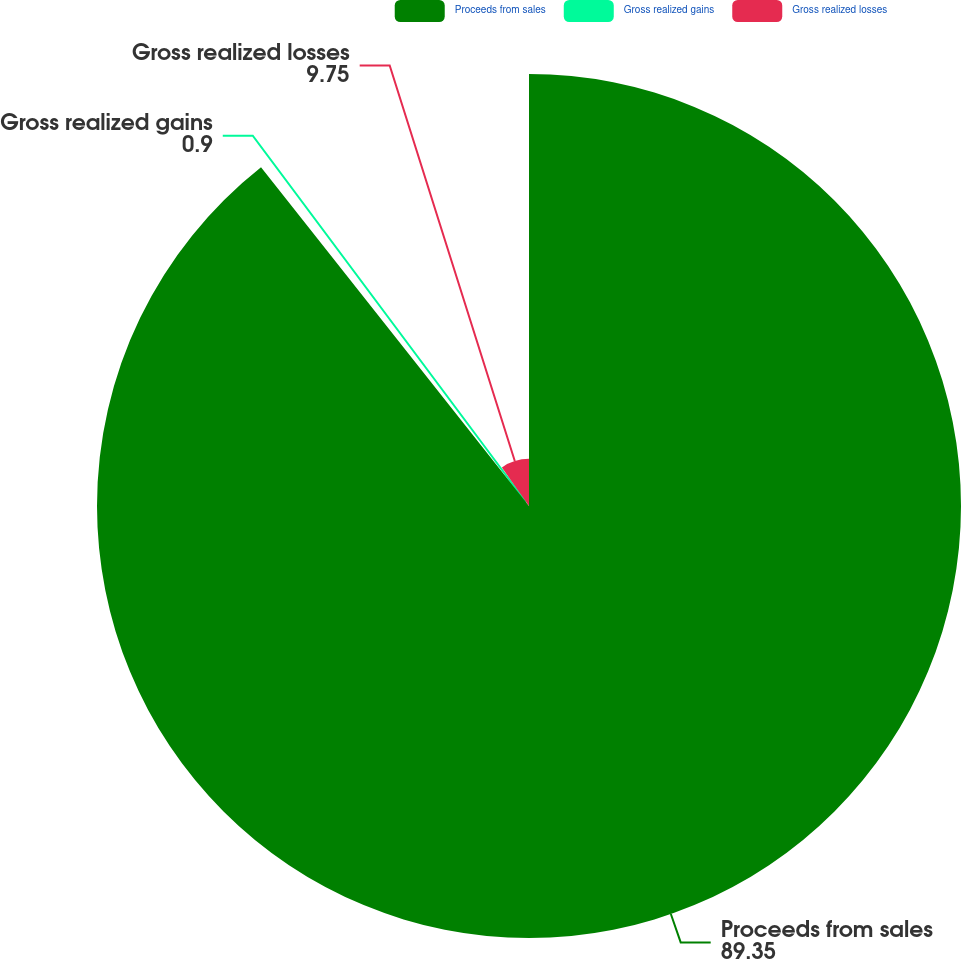Convert chart. <chart><loc_0><loc_0><loc_500><loc_500><pie_chart><fcel>Proceeds from sales<fcel>Gross realized gains<fcel>Gross realized losses<nl><fcel>89.35%<fcel>0.9%<fcel>9.75%<nl></chart> 